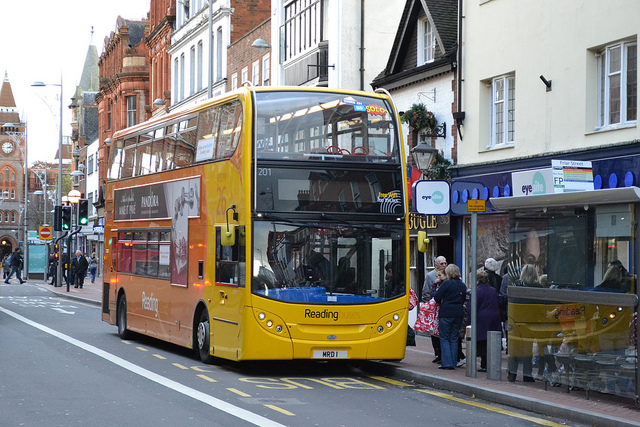Please transcribe the text information in this image. Reading HROI 201 eye 30GLE 